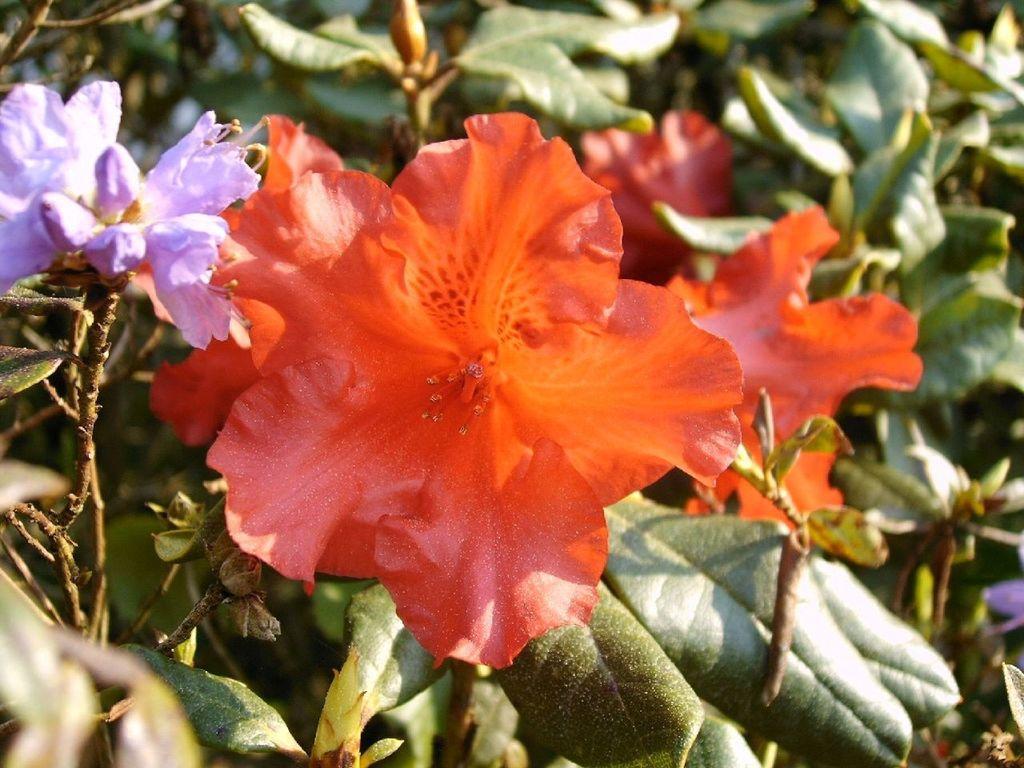How would you summarize this image in a sentence or two? In this image there are plants with colorful flowers. 